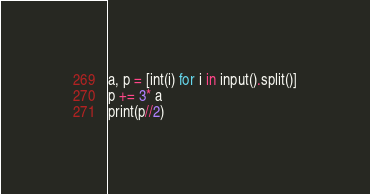<code> <loc_0><loc_0><loc_500><loc_500><_Python_>a, p = [int(i) for i in input().split()]
p += 3* a
print(p//2)</code> 